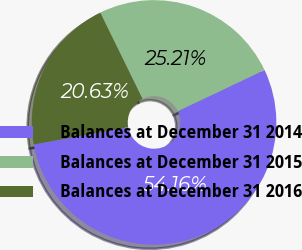Convert chart. <chart><loc_0><loc_0><loc_500><loc_500><pie_chart><fcel>Balances at December 31 2014<fcel>Balances at December 31 2015<fcel>Balances at December 31 2016<nl><fcel>54.17%<fcel>25.21%<fcel>20.63%<nl></chart> 